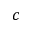Convert formula to latex. <formula><loc_0><loc_0><loc_500><loc_500>c</formula> 